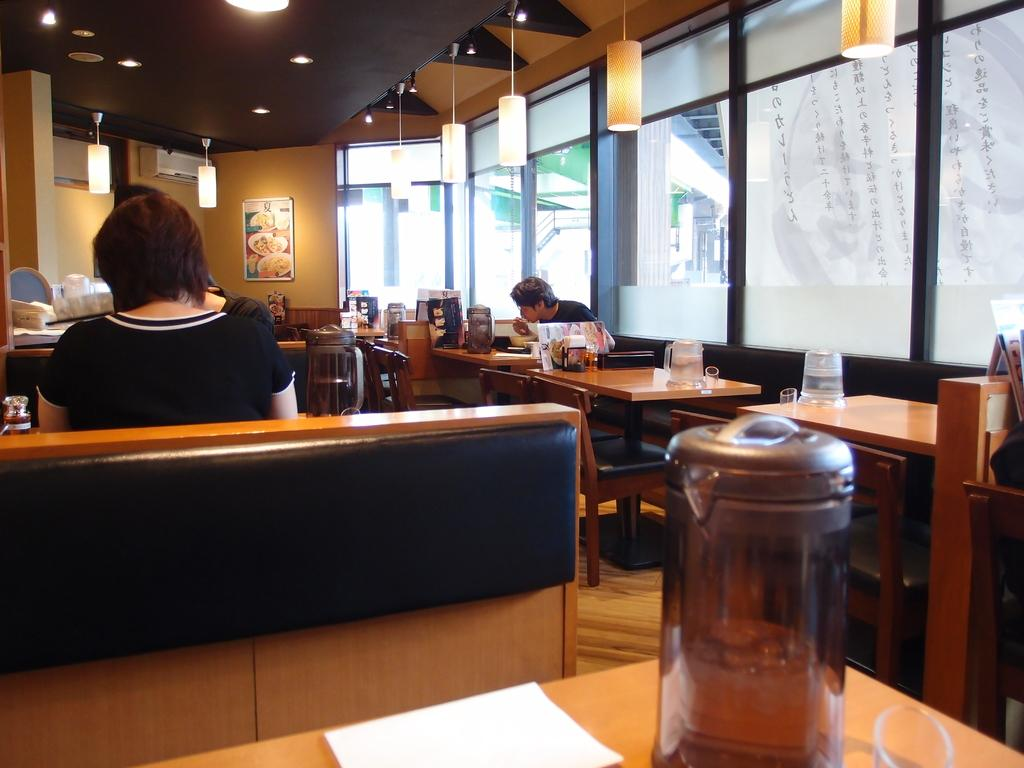What type of furniture is visible in the image? There are chairs and tables in the image. What is placed on the tables? There are things on the tables. Can you describe the people in the image? There are people in the image. What can be seen in the background of the image? There are windows, lights, a wall, and a ceiling in the background of the image. What type of hat is being worn by the person in the garden in the image? There is no garden or person wearing a hat in the image. 